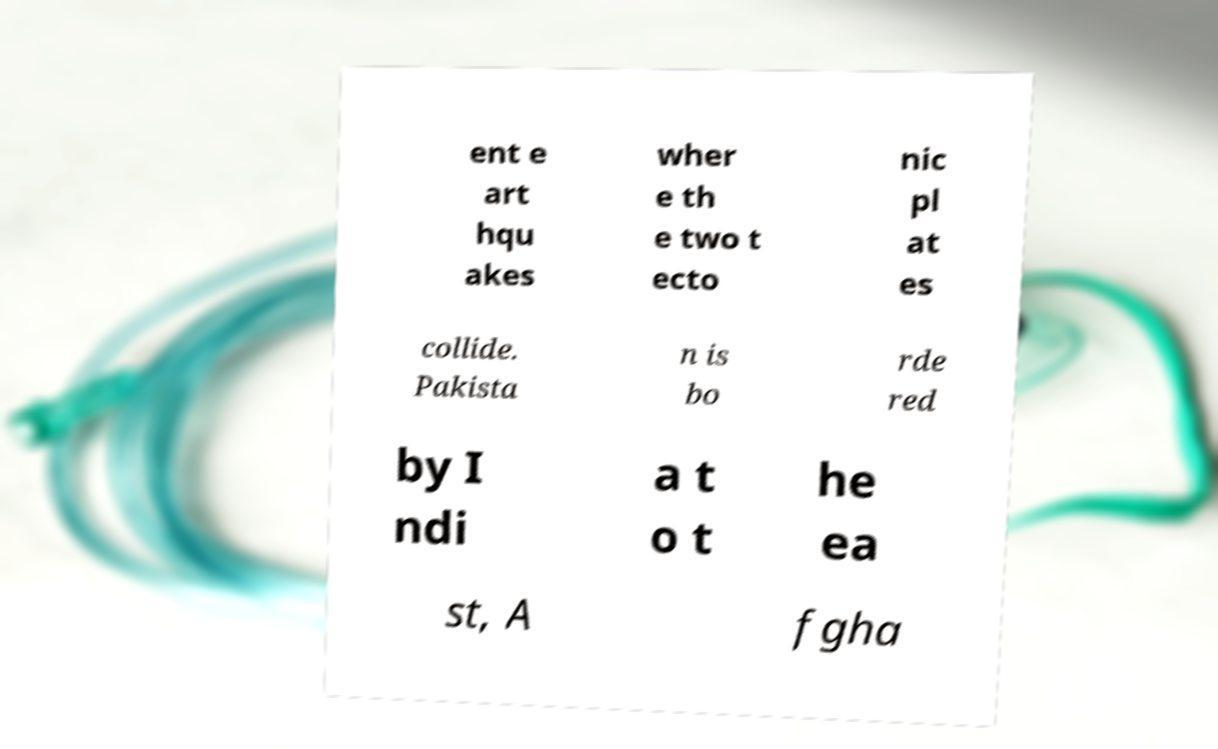Please identify and transcribe the text found in this image. ent e art hqu akes wher e th e two t ecto nic pl at es collide. Pakista n is bo rde red by I ndi a t o t he ea st, A fgha 